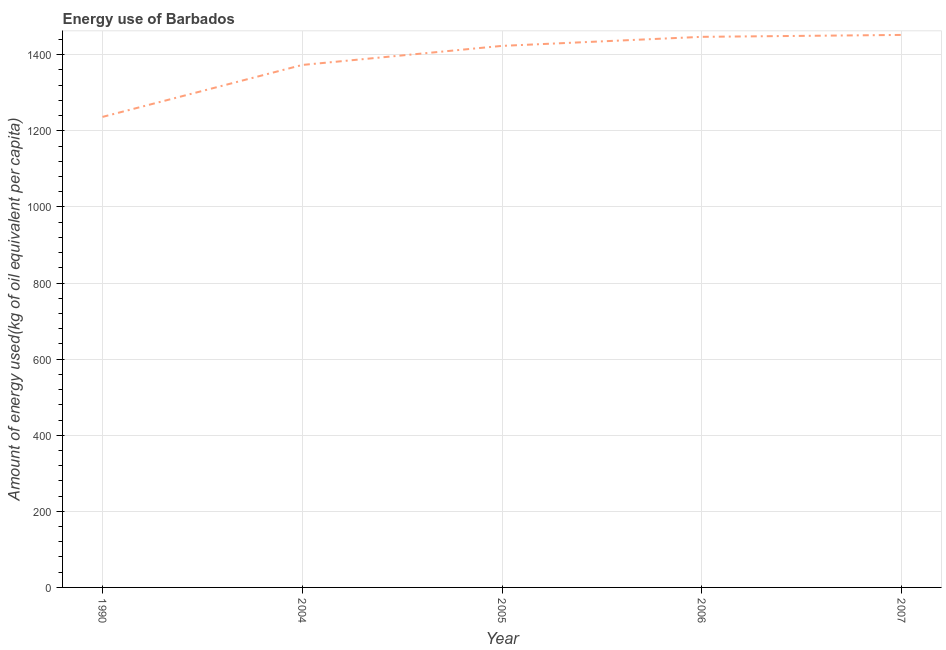What is the amount of energy used in 1990?
Keep it short and to the point. 1236.64. Across all years, what is the maximum amount of energy used?
Make the answer very short. 1452.09. Across all years, what is the minimum amount of energy used?
Provide a short and direct response. 1236.64. In which year was the amount of energy used minimum?
Provide a short and direct response. 1990. What is the sum of the amount of energy used?
Your response must be concise. 6932.25. What is the difference between the amount of energy used in 2004 and 2007?
Provide a succinct answer. -78.92. What is the average amount of energy used per year?
Offer a very short reply. 1386.45. What is the median amount of energy used?
Provide a succinct answer. 1423.29. What is the ratio of the amount of energy used in 2004 to that in 2005?
Your answer should be very brief. 0.96. What is the difference between the highest and the second highest amount of energy used?
Give a very brief answer. 5.03. Is the sum of the amount of energy used in 2004 and 2007 greater than the maximum amount of energy used across all years?
Offer a very short reply. Yes. What is the difference between the highest and the lowest amount of energy used?
Provide a succinct answer. 215.45. What is the difference between two consecutive major ticks on the Y-axis?
Ensure brevity in your answer.  200. Does the graph contain any zero values?
Make the answer very short. No. What is the title of the graph?
Ensure brevity in your answer.  Energy use of Barbados. What is the label or title of the Y-axis?
Provide a succinct answer. Amount of energy used(kg of oil equivalent per capita). What is the Amount of energy used(kg of oil equivalent per capita) of 1990?
Your response must be concise. 1236.64. What is the Amount of energy used(kg of oil equivalent per capita) in 2004?
Make the answer very short. 1373.17. What is the Amount of energy used(kg of oil equivalent per capita) in 2005?
Offer a terse response. 1423.29. What is the Amount of energy used(kg of oil equivalent per capita) of 2006?
Make the answer very short. 1447.06. What is the Amount of energy used(kg of oil equivalent per capita) of 2007?
Make the answer very short. 1452.09. What is the difference between the Amount of energy used(kg of oil equivalent per capita) in 1990 and 2004?
Offer a very short reply. -136.53. What is the difference between the Amount of energy used(kg of oil equivalent per capita) in 1990 and 2005?
Provide a short and direct response. -186.65. What is the difference between the Amount of energy used(kg of oil equivalent per capita) in 1990 and 2006?
Provide a succinct answer. -210.42. What is the difference between the Amount of energy used(kg of oil equivalent per capita) in 1990 and 2007?
Your answer should be compact. -215.45. What is the difference between the Amount of energy used(kg of oil equivalent per capita) in 2004 and 2005?
Ensure brevity in your answer.  -50.12. What is the difference between the Amount of energy used(kg of oil equivalent per capita) in 2004 and 2006?
Your answer should be compact. -73.89. What is the difference between the Amount of energy used(kg of oil equivalent per capita) in 2004 and 2007?
Make the answer very short. -78.92. What is the difference between the Amount of energy used(kg of oil equivalent per capita) in 2005 and 2006?
Provide a succinct answer. -23.77. What is the difference between the Amount of energy used(kg of oil equivalent per capita) in 2005 and 2007?
Provide a succinct answer. -28.8. What is the difference between the Amount of energy used(kg of oil equivalent per capita) in 2006 and 2007?
Ensure brevity in your answer.  -5.03. What is the ratio of the Amount of energy used(kg of oil equivalent per capita) in 1990 to that in 2004?
Provide a short and direct response. 0.9. What is the ratio of the Amount of energy used(kg of oil equivalent per capita) in 1990 to that in 2005?
Ensure brevity in your answer.  0.87. What is the ratio of the Amount of energy used(kg of oil equivalent per capita) in 1990 to that in 2006?
Make the answer very short. 0.85. What is the ratio of the Amount of energy used(kg of oil equivalent per capita) in 1990 to that in 2007?
Keep it short and to the point. 0.85. What is the ratio of the Amount of energy used(kg of oil equivalent per capita) in 2004 to that in 2005?
Ensure brevity in your answer.  0.96. What is the ratio of the Amount of energy used(kg of oil equivalent per capita) in 2004 to that in 2006?
Offer a terse response. 0.95. What is the ratio of the Amount of energy used(kg of oil equivalent per capita) in 2004 to that in 2007?
Keep it short and to the point. 0.95. 